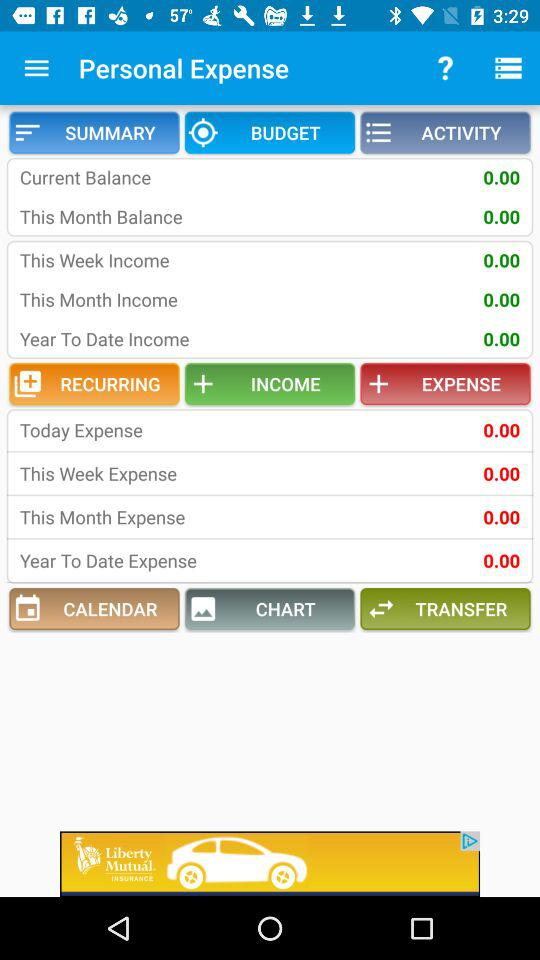What is the current balance? The current balance is 0.00. 